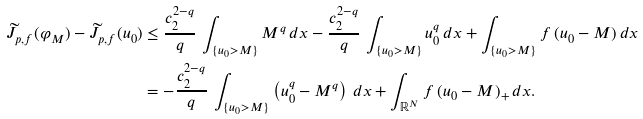Convert formula to latex. <formula><loc_0><loc_0><loc_500><loc_500>\widetilde { J } _ { p , f } ( \varphi _ { M } ) - \widetilde { J } _ { p , f } ( u _ { 0 } ) & \leq \frac { c _ { 2 } ^ { 2 - q } } { q } \, \int _ { \{ u _ { 0 } > M \} } M ^ { q } \, d x - \frac { c _ { 2 } ^ { 2 - q } } { q } \, \int _ { \{ u _ { 0 } > M \} } u _ { 0 } ^ { q } \, d x + \int _ { \{ u _ { 0 } > M \} } f \, ( u _ { 0 } - M ) \, d x \\ & = - \frac { c _ { 2 } ^ { 2 - q } } { q } \, \int _ { \{ u _ { 0 } > M \} } \left ( u _ { 0 } ^ { q } - M ^ { q } \right ) \, d x + \int _ { \mathbb { R } ^ { N } } f \, ( u _ { 0 } - M ) _ { + } \, d x . \\</formula> 